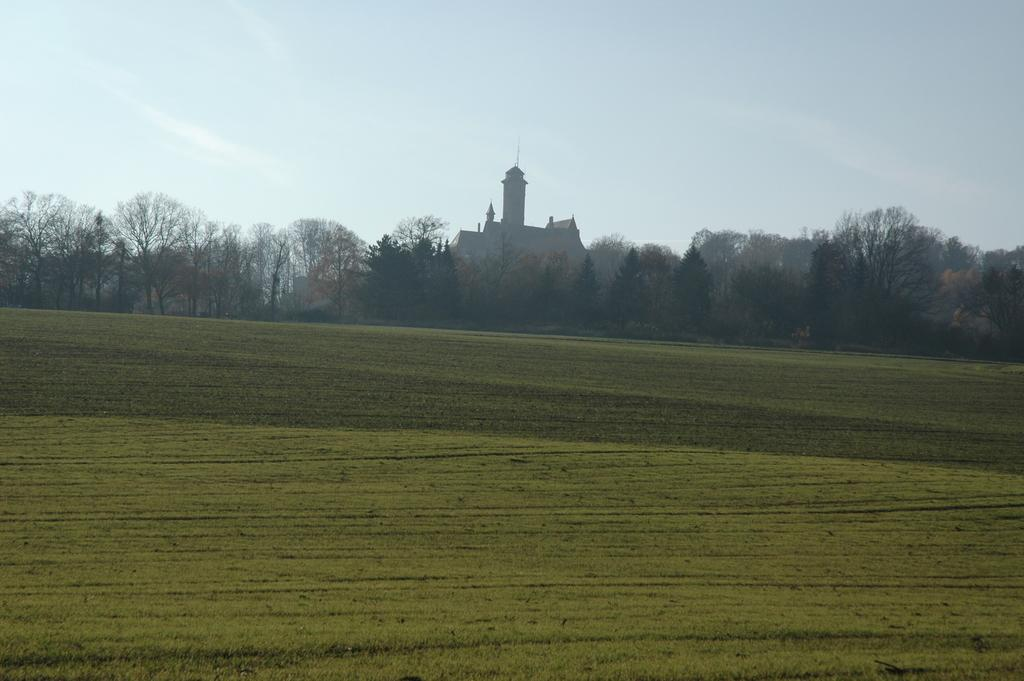What type of vegetation can be seen in the image? There are trees in the image. What structures are present in the image? There are buildings in the image. What is at the bottom of the image? There is grass at the bottom of the image. What is visible in the background of the image? The sky is visible in the background of the image. What type of stew is being prepared in the image? There is no stew present in the image; it features trees, buildings, grass, and the sky. What is the chance of rain in the image? The image does not provide any information about the weather or the chance of rain. 